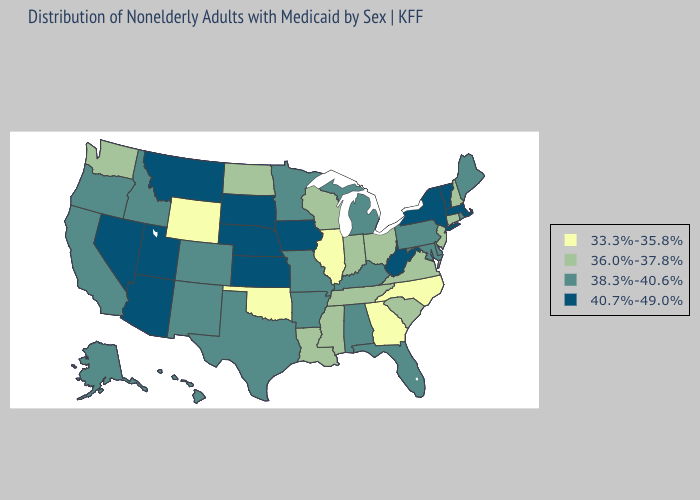Name the states that have a value in the range 40.7%-49.0%?
Concise answer only. Arizona, Iowa, Kansas, Massachusetts, Montana, Nebraska, Nevada, New York, South Dakota, Utah, Vermont, West Virginia. Does New Jersey have a higher value than Arizona?
Give a very brief answer. No. Name the states that have a value in the range 40.7%-49.0%?
Concise answer only. Arizona, Iowa, Kansas, Massachusetts, Montana, Nebraska, Nevada, New York, South Dakota, Utah, Vermont, West Virginia. What is the lowest value in the USA?
Quick response, please. 33.3%-35.8%. Among the states that border Massachusetts , does Connecticut have the lowest value?
Be succinct. Yes. Which states hav the highest value in the MidWest?
Short answer required. Iowa, Kansas, Nebraska, South Dakota. Among the states that border Colorado , does Utah have the lowest value?
Give a very brief answer. No. Name the states that have a value in the range 36.0%-37.8%?
Keep it brief. Connecticut, Indiana, Louisiana, Mississippi, New Hampshire, New Jersey, North Dakota, Ohio, South Carolina, Tennessee, Virginia, Washington, Wisconsin. Does Arizona have the highest value in the USA?
Keep it brief. Yes. Name the states that have a value in the range 33.3%-35.8%?
Answer briefly. Georgia, Illinois, North Carolina, Oklahoma, Wyoming. What is the highest value in the West ?
Write a very short answer. 40.7%-49.0%. What is the highest value in the USA?
Short answer required. 40.7%-49.0%. Does Louisiana have a higher value than North Carolina?
Keep it brief. Yes. What is the lowest value in the MidWest?
Concise answer only. 33.3%-35.8%. What is the highest value in the West ?
Keep it brief. 40.7%-49.0%. 